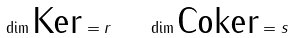Convert formula to latex. <formula><loc_0><loc_0><loc_500><loc_500>\dim \text {Ker} = r \quad \dim \text {Coker} = s</formula> 